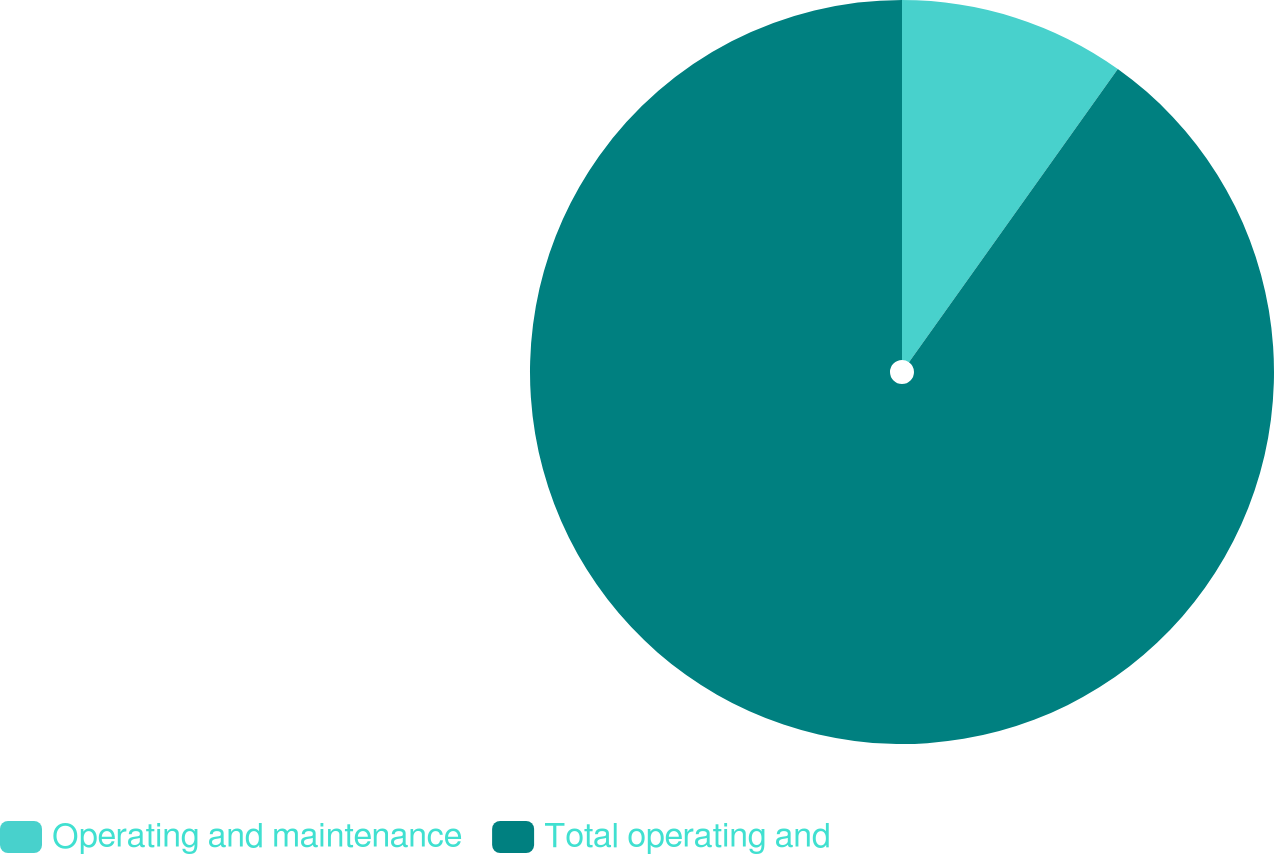Convert chart to OTSL. <chart><loc_0><loc_0><loc_500><loc_500><pie_chart><fcel>Operating and maintenance<fcel>Total operating and<nl><fcel>9.85%<fcel>90.15%<nl></chart> 